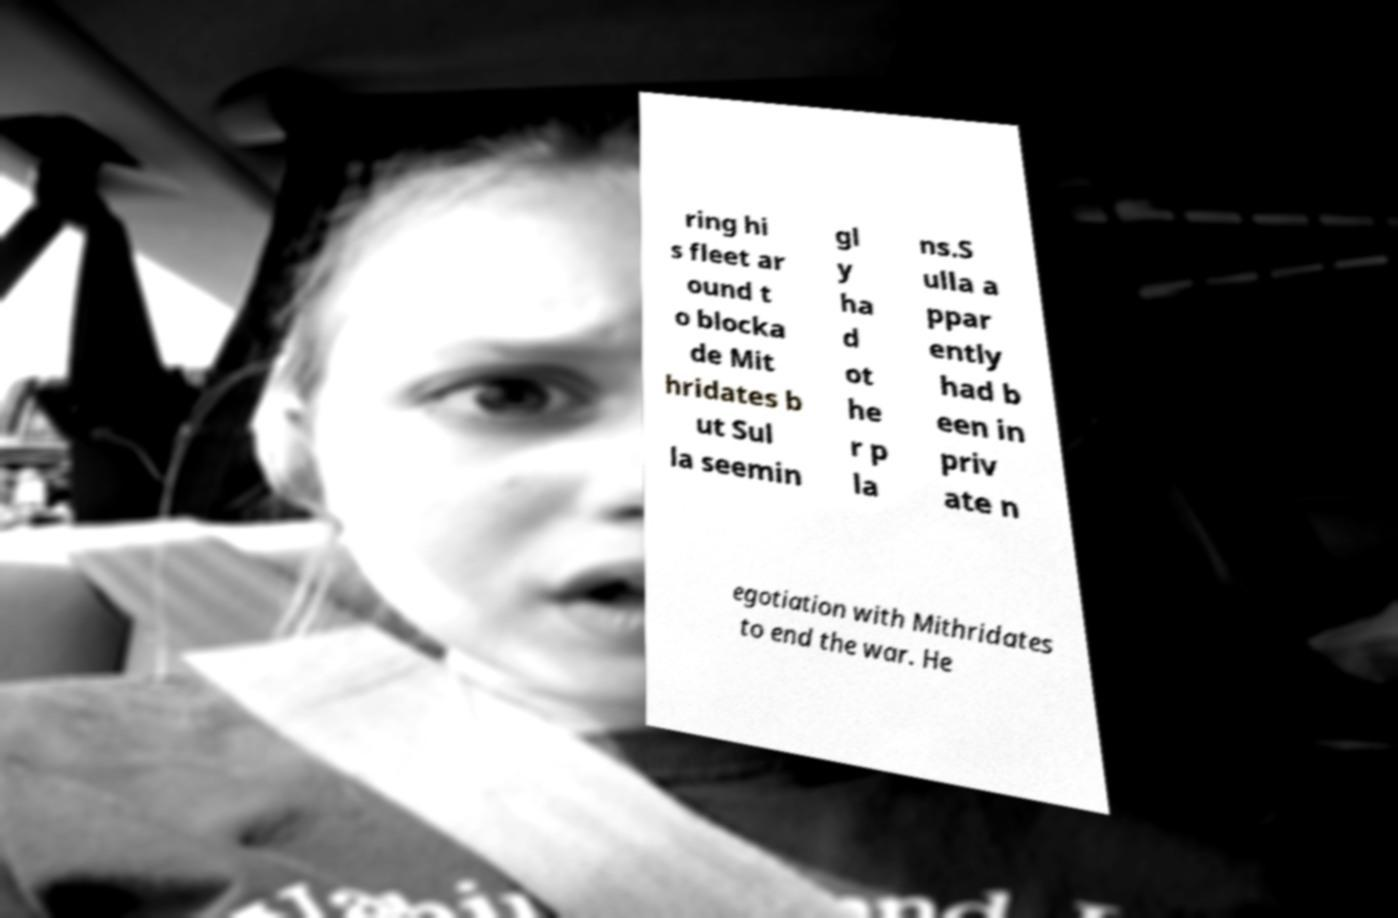There's text embedded in this image that I need extracted. Can you transcribe it verbatim? ring hi s fleet ar ound t o blocka de Mit hridates b ut Sul la seemin gl y ha d ot he r p la ns.S ulla a ppar ently had b een in priv ate n egotiation with Mithridates to end the war. He 